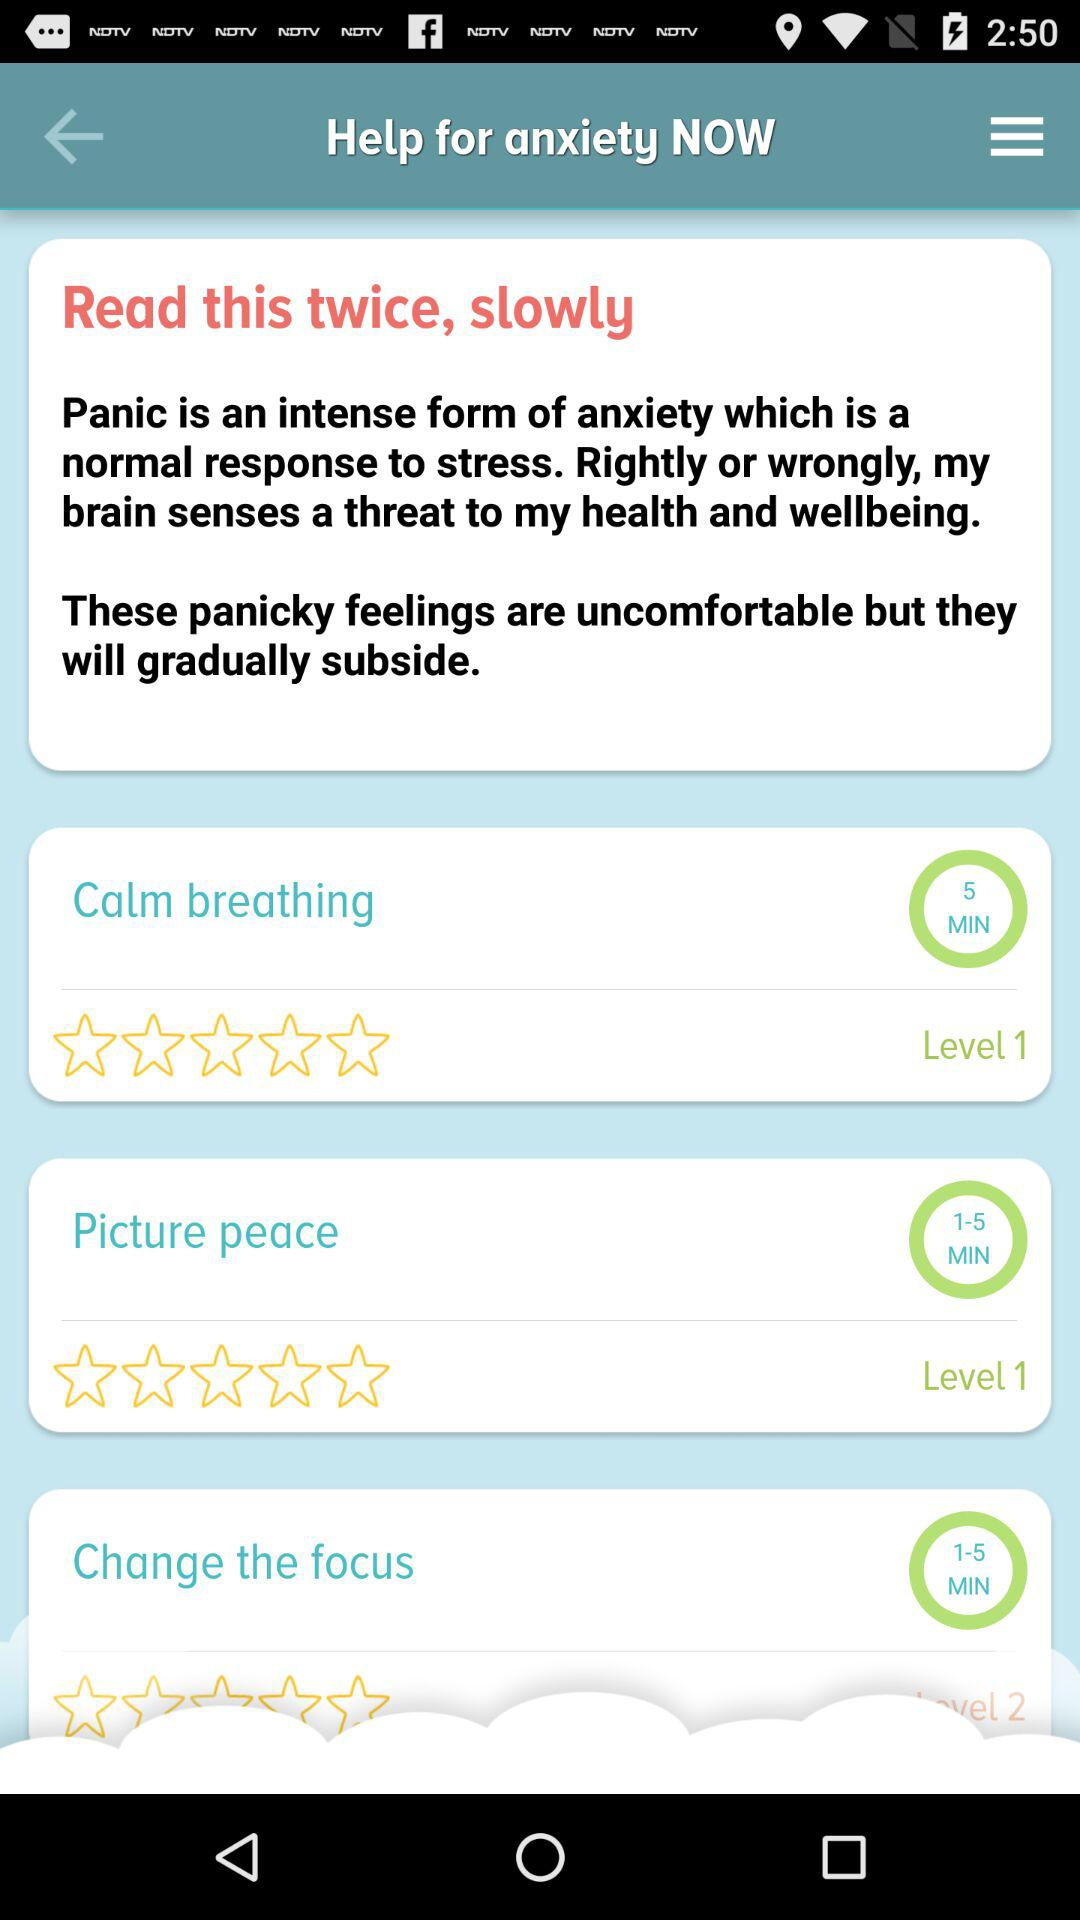What is the duration of picture peace? The duration of picture peace is 1–5 minutes. 